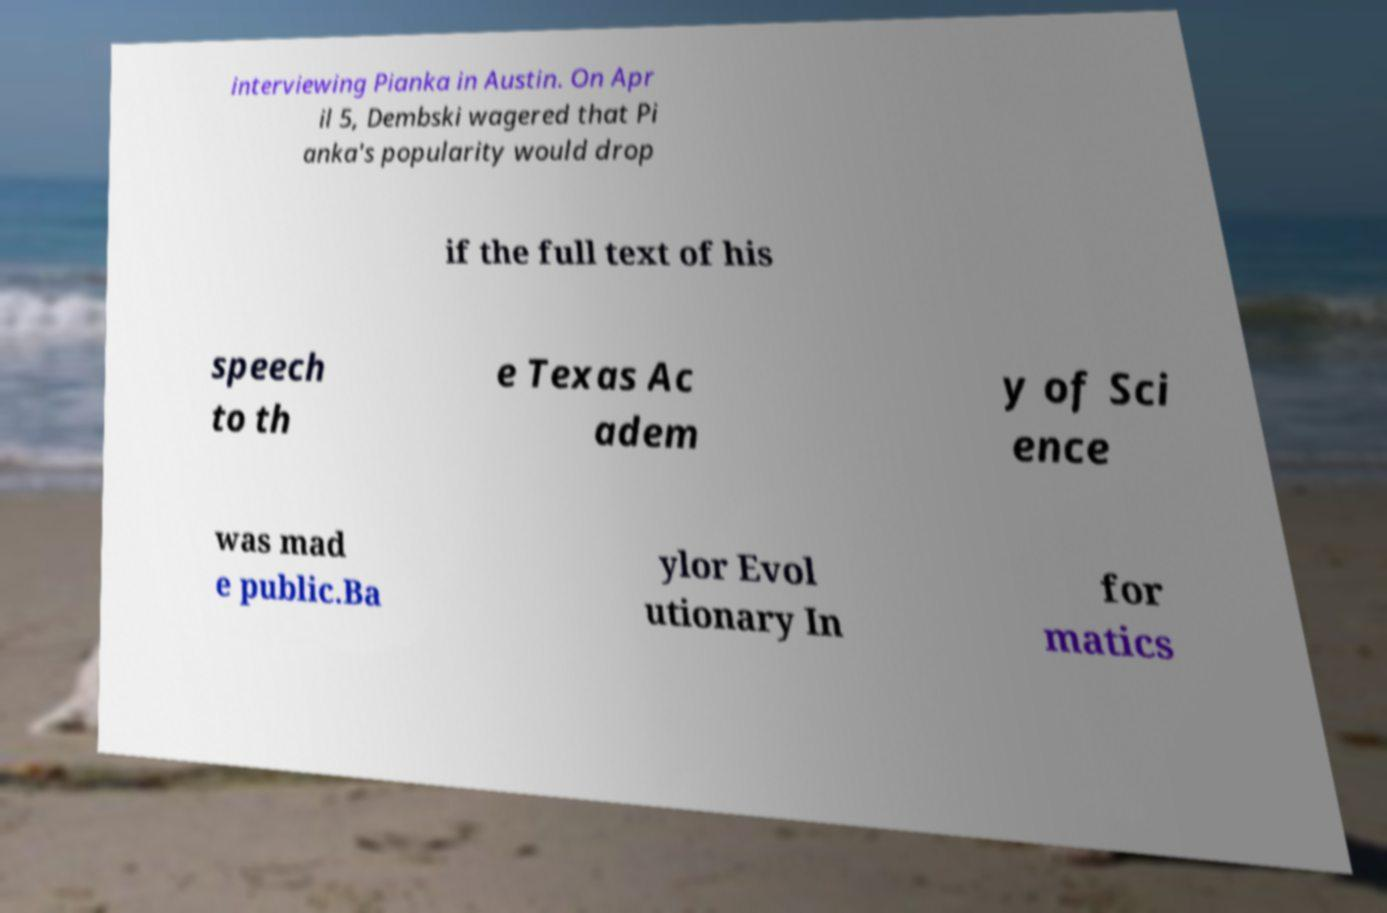What messages or text are displayed in this image? I need them in a readable, typed format. interviewing Pianka in Austin. On Apr il 5, Dembski wagered that Pi anka's popularity would drop if the full text of his speech to th e Texas Ac adem y of Sci ence was mad e public.Ba ylor Evol utionary In for matics 